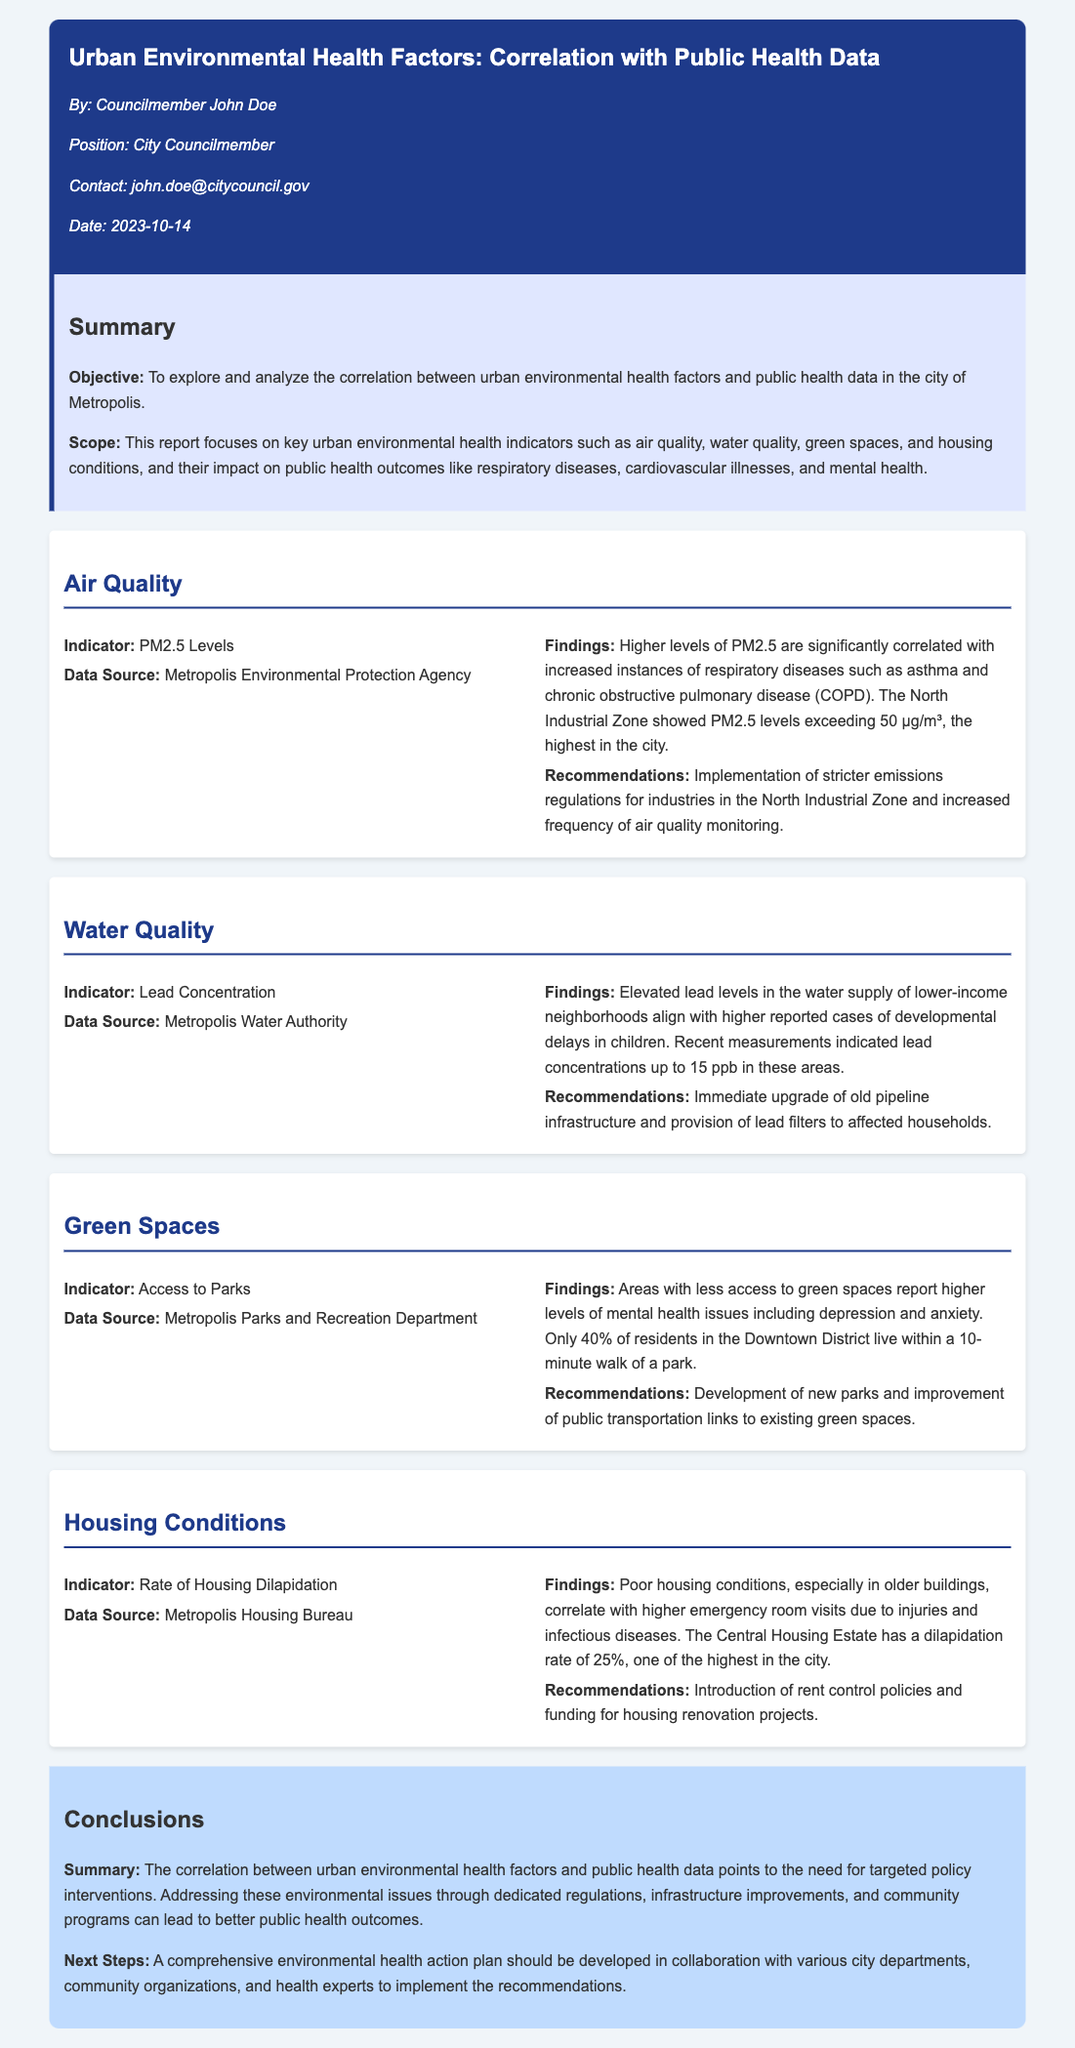What is the main objective of the report? The objective is to explore and analyze the correlation between urban environmental health factors and public health data in the city of Metropolis.
Answer: To explore and analyze the correlation between urban environmental health factors and public health data in the city of Metropolis What is the PM2.5 level threshold identified in the North Industrial Zone? The findings state that PM2.5 levels exceeding 50 µg/m³ were identified in the North Industrial Zone.
Answer: 50 µg/m³ What is the lead concentration level reported in lower-income neighborhoods? Recent measurements indicated lead concentrations up to 15 ppb in lower-income neighborhoods.
Answer: 15 ppb What percentage of Downtown District residents live within a 10-minute walk of a park? The document states that only 40% of residents in the Downtown District live within a 10-minute walk of a park.
Answer: 40% What is the rate of housing dilapidation in the Central Housing Estate? The document specifies that the Central Housing Estate has a dilapidation rate of 25%.
Answer: 25% What is a recommended action for addressing poor air quality? The recommendations include implementation of stricter emissions regulations for industries in the North Industrial Zone.
Answer: Stricter emissions regulations What correlates with higher levels of mental health issues according to the report? The report states that areas with less access to green spaces report higher levels of mental health issues.
Answer: Access to green spaces What is the next step outlined in the conclusions? The next step involves developing a comprehensive environmental health action plan in collaboration with various entities.
Answer: Environmental health action plan What type of diseases are correlated with housing conditions according to the findings? The findings indicated that poor housing conditions correlate with higher emergency room visits due to injuries and infectious diseases.
Answer: Injuries and infectious diseases 